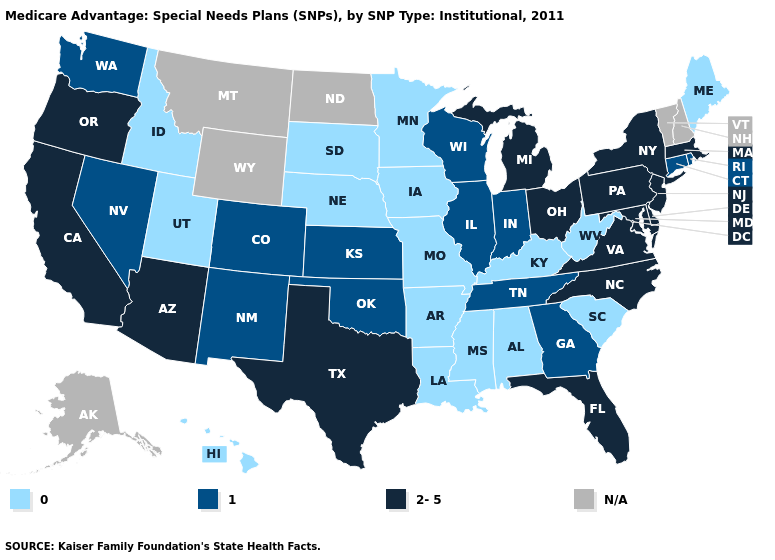Does New Jersey have the lowest value in the USA?
Quick response, please. No. What is the lowest value in the Northeast?
Short answer required. 0. What is the value of Nebraska?
Give a very brief answer. 0. Name the states that have a value in the range 1?
Keep it brief. Colorado, Connecticut, Georgia, Illinois, Indiana, Kansas, New Mexico, Nevada, Oklahoma, Rhode Island, Tennessee, Washington, Wisconsin. What is the lowest value in the USA?
Be succinct. 0. Does Nevada have the highest value in the USA?
Concise answer only. No. Name the states that have a value in the range 1?
Answer briefly. Colorado, Connecticut, Georgia, Illinois, Indiana, Kansas, New Mexico, Nevada, Oklahoma, Rhode Island, Tennessee, Washington, Wisconsin. Which states hav the highest value in the West?
Short answer required. Arizona, California, Oregon. What is the lowest value in the Northeast?
Quick response, please. 0. Does Louisiana have the lowest value in the USA?
Give a very brief answer. Yes. Name the states that have a value in the range 2-5?
Concise answer only. Arizona, California, Delaware, Florida, Massachusetts, Maryland, Michigan, North Carolina, New Jersey, New York, Ohio, Oregon, Pennsylvania, Texas, Virginia. Among the states that border Pennsylvania , which have the highest value?
Answer briefly. Delaware, Maryland, New Jersey, New York, Ohio. Does Nebraska have the highest value in the USA?
Short answer required. No. Is the legend a continuous bar?
Keep it brief. No. What is the value of Ohio?
Answer briefly. 2-5. 